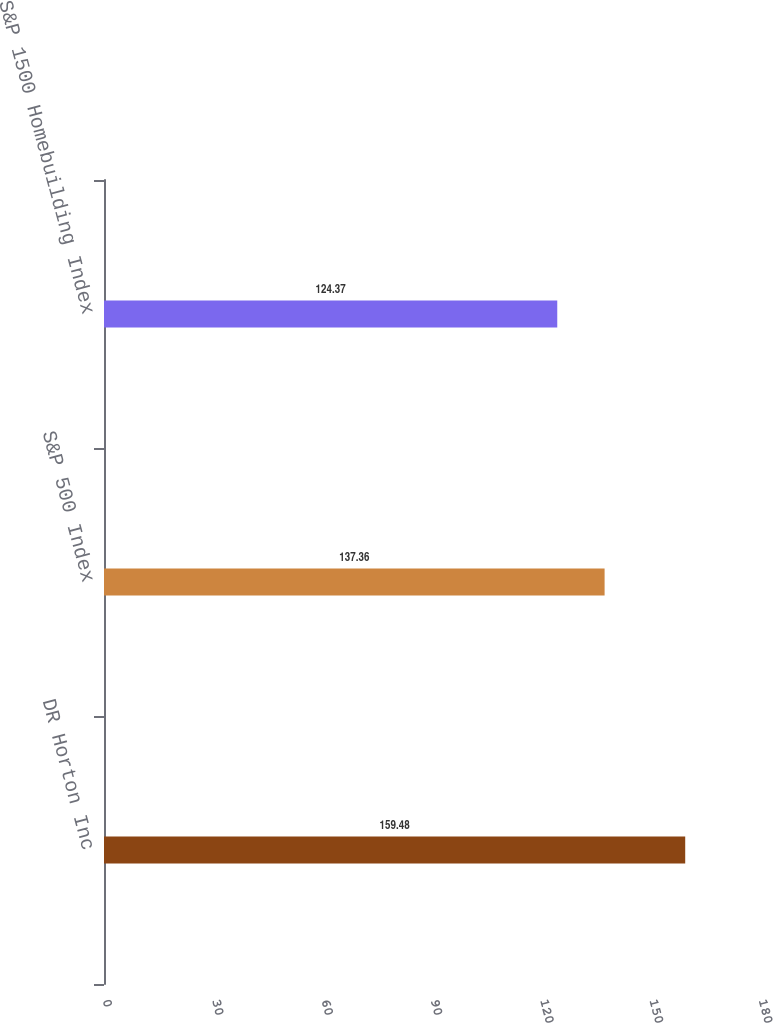<chart> <loc_0><loc_0><loc_500><loc_500><bar_chart><fcel>DR Horton Inc<fcel>S&P 500 Index<fcel>S&P 1500 Homebuilding Index<nl><fcel>159.48<fcel>137.36<fcel>124.37<nl></chart> 